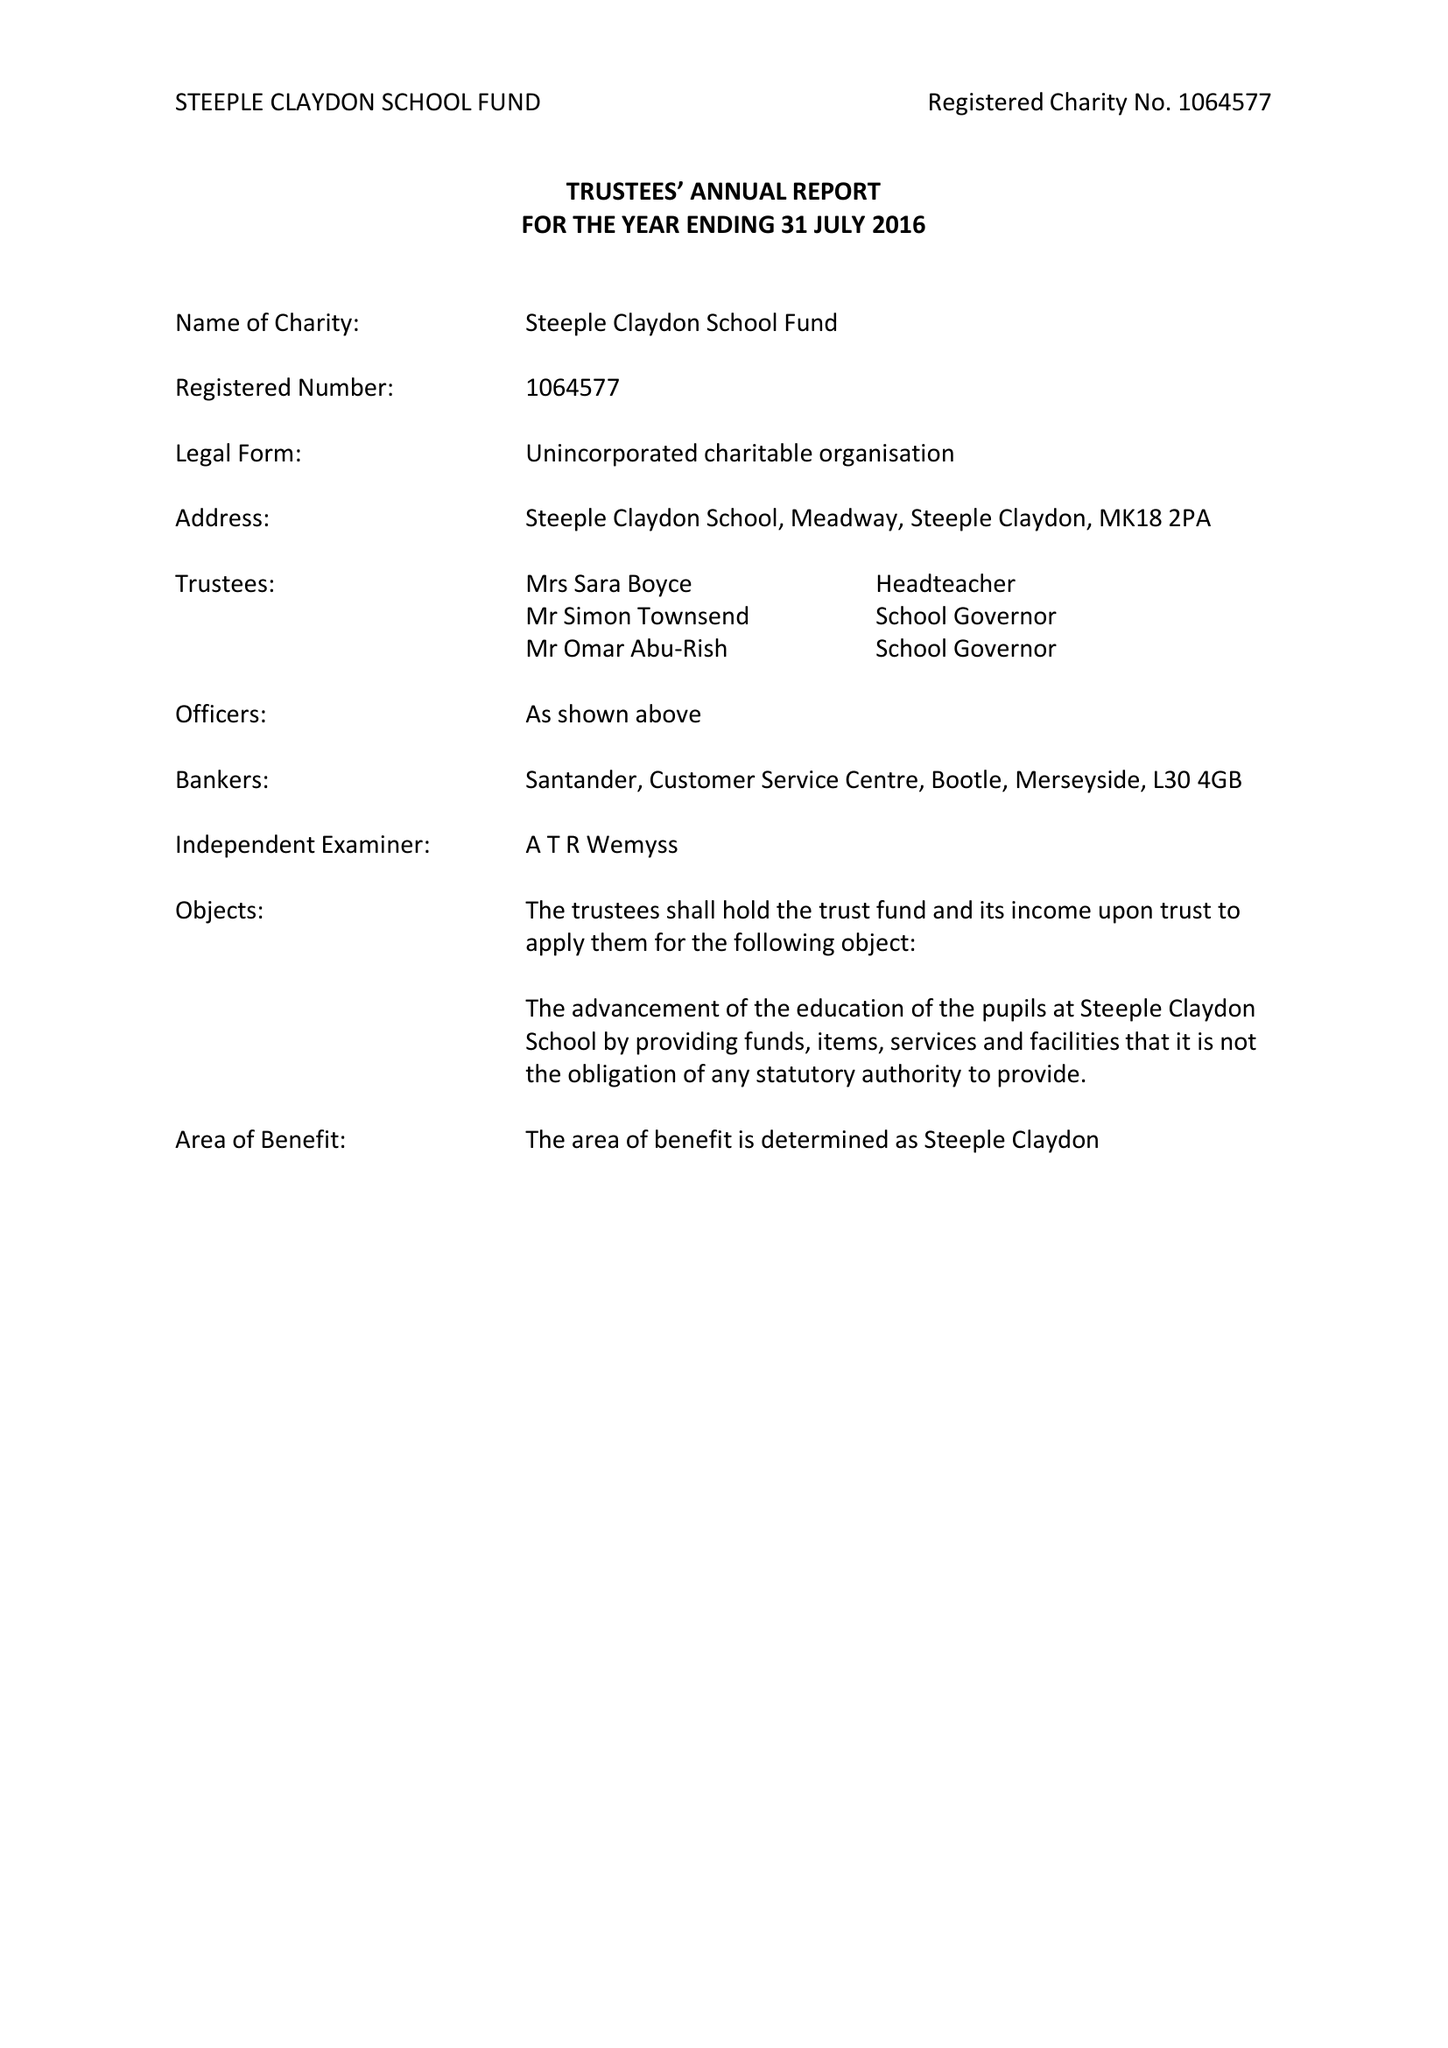What is the value for the report_date?
Answer the question using a single word or phrase. 2017-08-31 